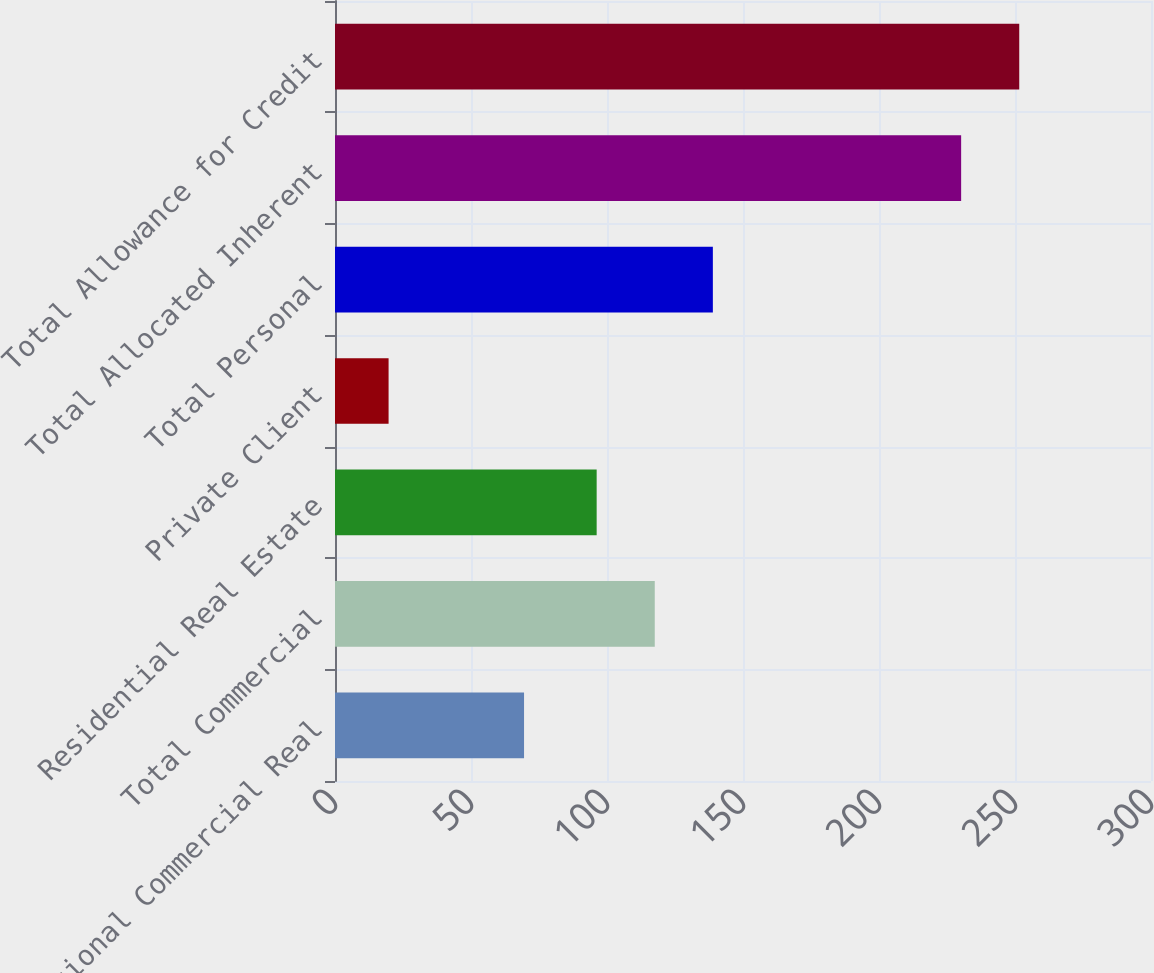<chart> <loc_0><loc_0><loc_500><loc_500><bar_chart><fcel>Institutional Commercial Real<fcel>Total Commercial<fcel>Residential Real Estate<fcel>Private Client<fcel>Total Personal<fcel>Total Allocated Inherent<fcel>Total Allowance for Credit<nl><fcel>69.5<fcel>117.56<fcel>96.2<fcel>19.7<fcel>138.92<fcel>230.2<fcel>251.56<nl></chart> 